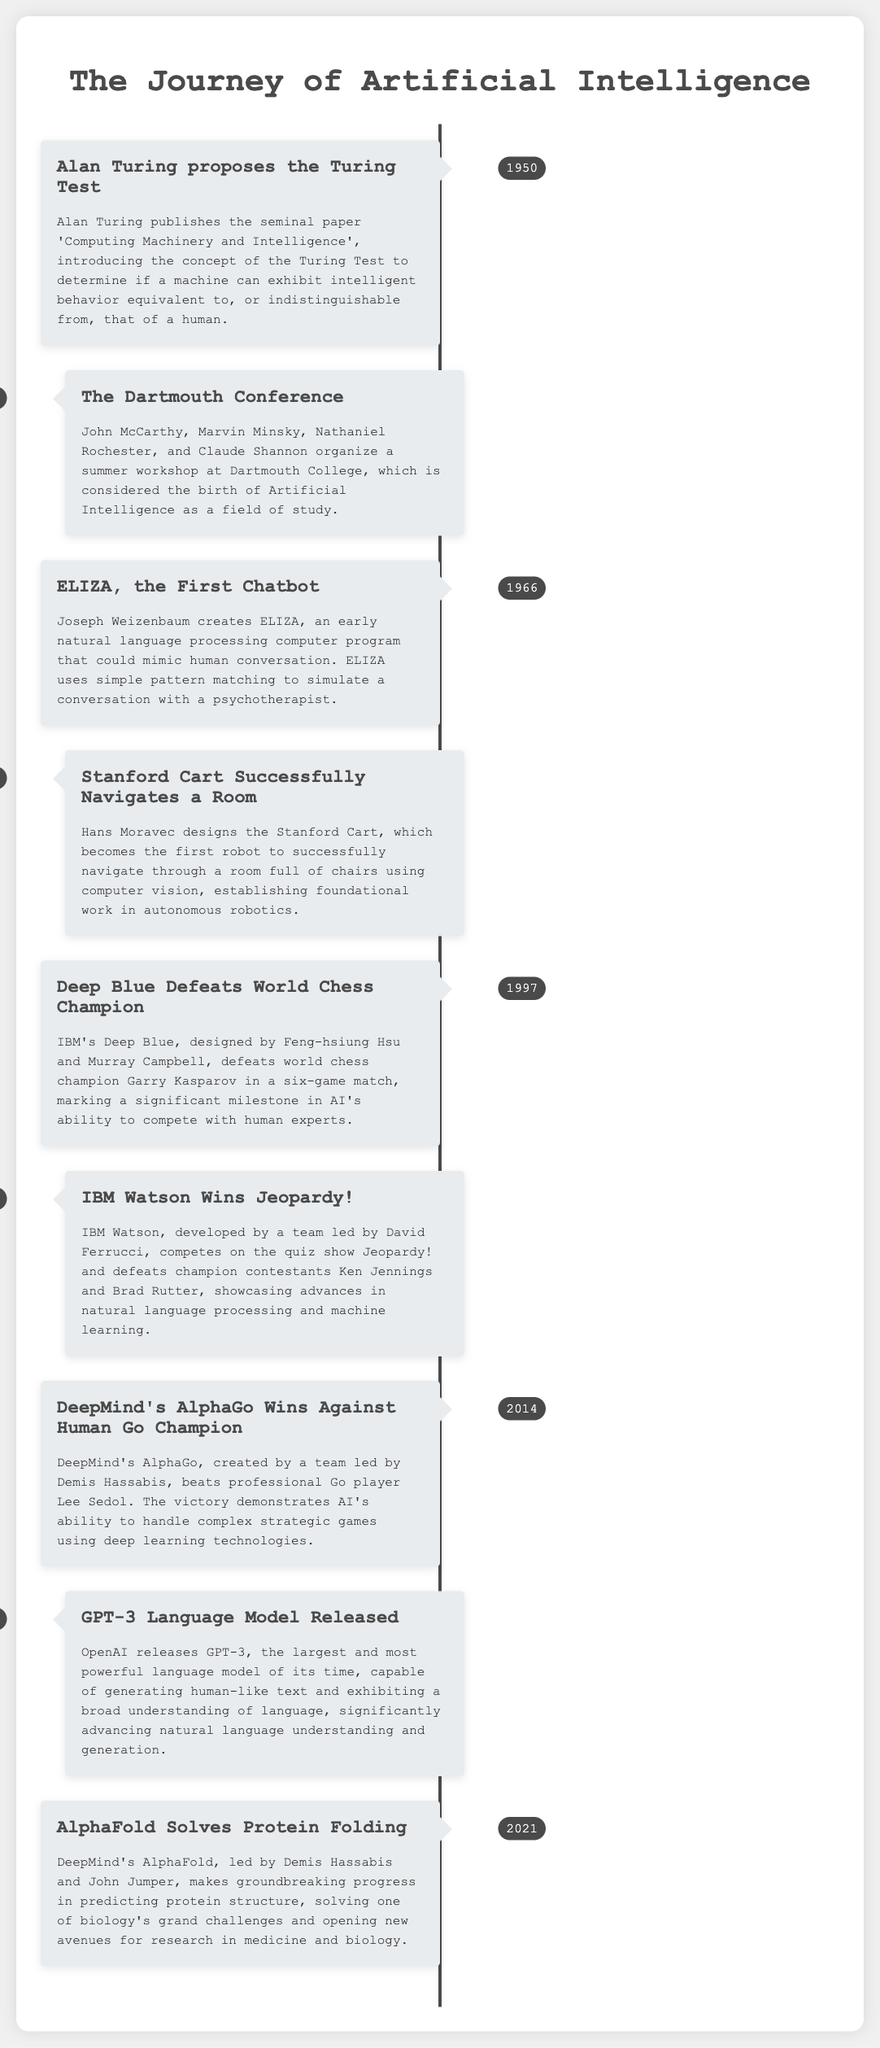What year did Alan Turing propose the Turing Test? Alan Turing proposed the Turing Test in the year mentioned in the document, which is 1950.
Answer: 1950 Who created the first chatbot named ELIZA? The document states that ELIZA was created by Joseph Weizenbaum.
Answer: Joseph Weizenbaum What significant event occurred in 1997 regarding Deep Blue? According to the timeline, Deep Blue defeated world chess champion Garry Kasparov in a six-game match in 1997.
Answer: Defeated Garry Kasparov Which application won Jeopardy! in 2011? The timeline mentions that IBM Watson won Jeopardy! in 2011.
Answer: IBM Watson Who led the team that developed AlphaFold? The document indicates that Demis Hassabis and John Jumper led the team that developed AlphaFold.
Answer: Demis Hassabis and John Jumper What does the Turing Test determine? The Turing Test introduced by Alan Turing determines if a machine can exhibit intelligent behavior equivalent to that of a human.
Answer: Intelligent behavior Which robot succeeded in navigating a room full of chairs? The timeline mentions that the Stanford Cart successfully navigated a room full of chairs.
Answer: Stanford Cart What milestone did GPT-3 achieve? According to the document, GPT-3 is noted for being the largest and most powerful language model of its time.
Answer: Largest and most powerful language model In what year did DeepMind's AlphaGo win against a human champion? The timeline states that DeepMind's AlphaGo won against human Go champion Lee Sedol in 2014.
Answer: 2014 